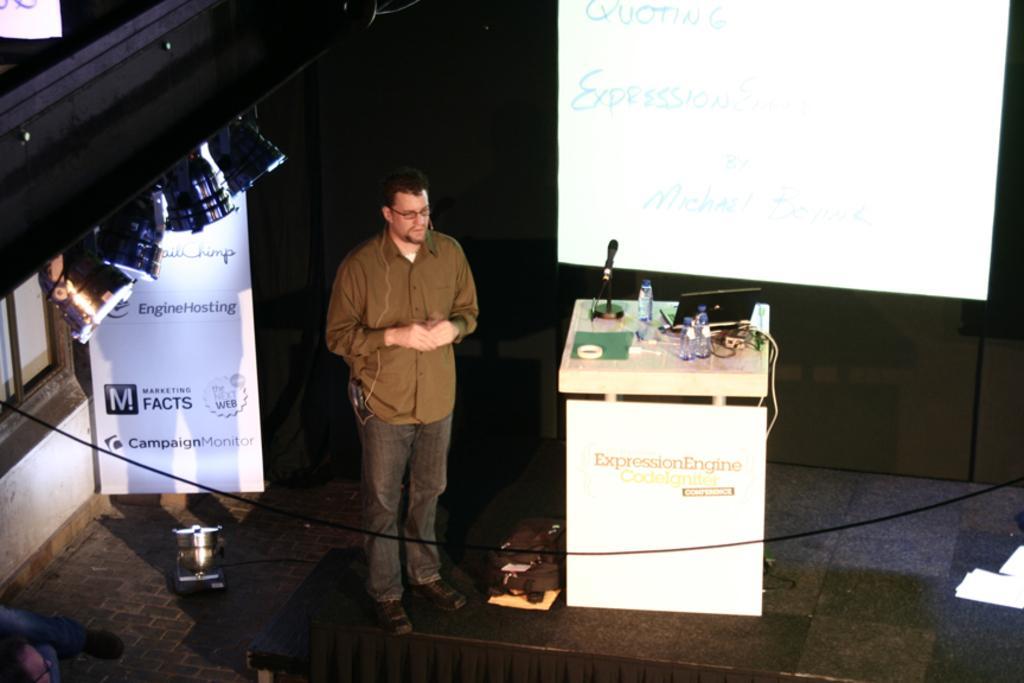Can you describe this image briefly? In this picture we can see a man standing on a stage and beside to him we can see a banner, screen, lights and a podium with bottles, mic, laptop on it. 